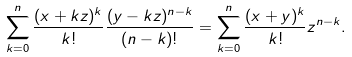<formula> <loc_0><loc_0><loc_500><loc_500>\sum _ { k = 0 } ^ { n } \frac { ( x + k z ) ^ { k } } { k ! } \frac { ( y - k z ) ^ { n - k } } { ( n - k ) ! } = \sum _ { k = 0 } ^ { n } \frac { ( x + y ) ^ { k } } { k ! } z ^ { n - k } .</formula> 